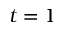<formula> <loc_0><loc_0><loc_500><loc_500>t = 1</formula> 